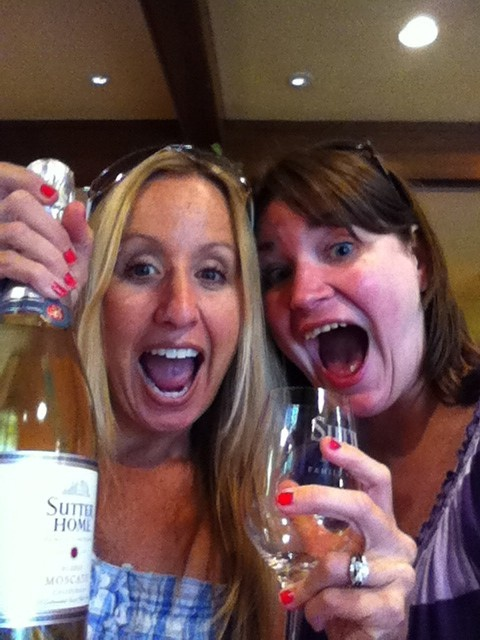Describe the objects in this image and their specific colors. I can see people in brown, maroon, and black tones, people in brown, black, maroon, and purple tones, bottle in brown, white, and maroon tones, and wine glass in brown, gray, black, and maroon tones in this image. 